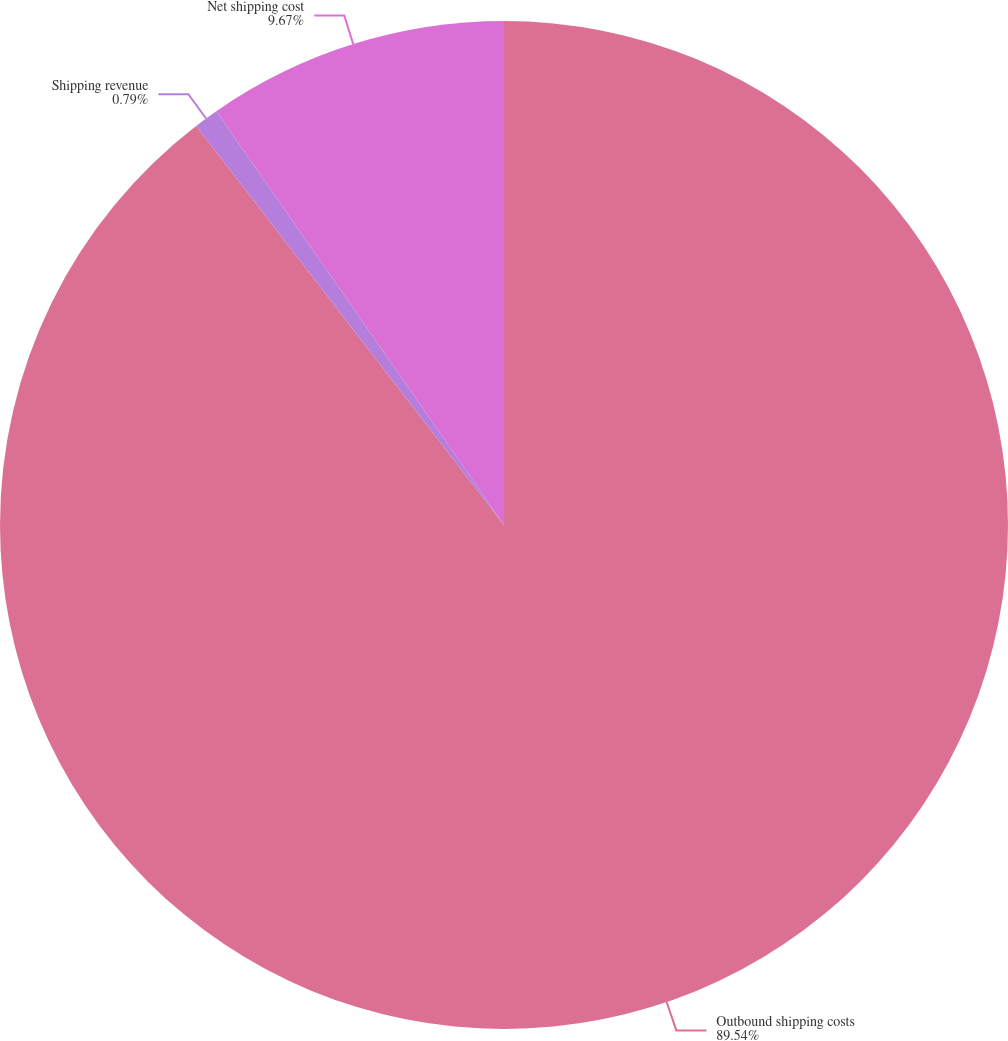<chart> <loc_0><loc_0><loc_500><loc_500><pie_chart><fcel>Outbound shipping costs<fcel>Shipping revenue<fcel>Net shipping cost<nl><fcel>89.54%<fcel>0.79%<fcel>9.67%<nl></chart> 